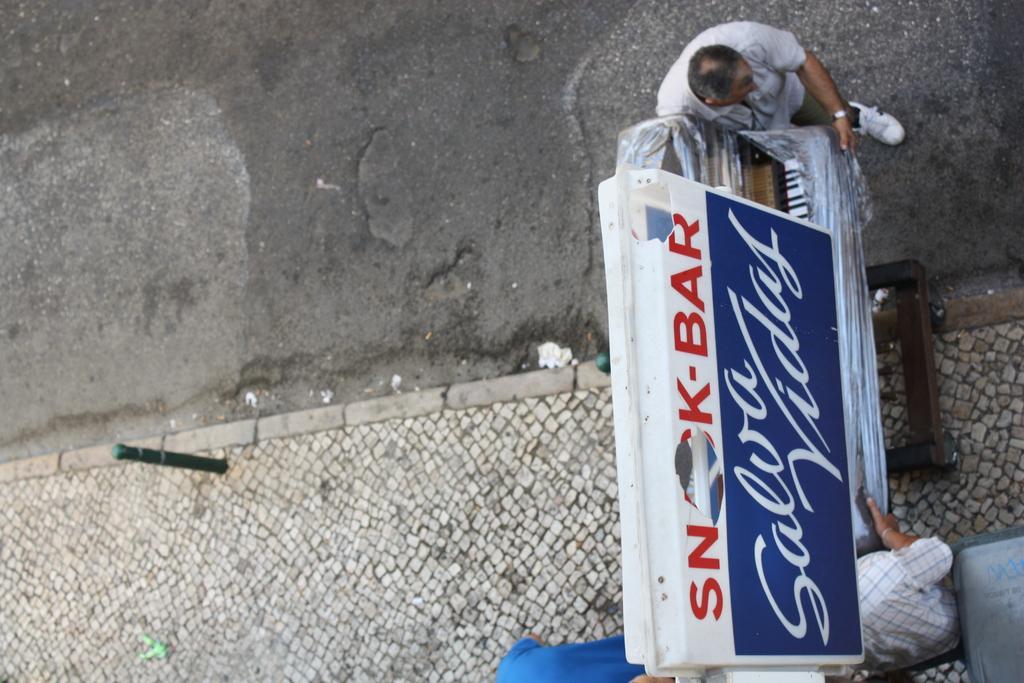Please provide a concise description of this image. In this picture we can see the road, footpath, pole, name board, stand, three people and some objects. 